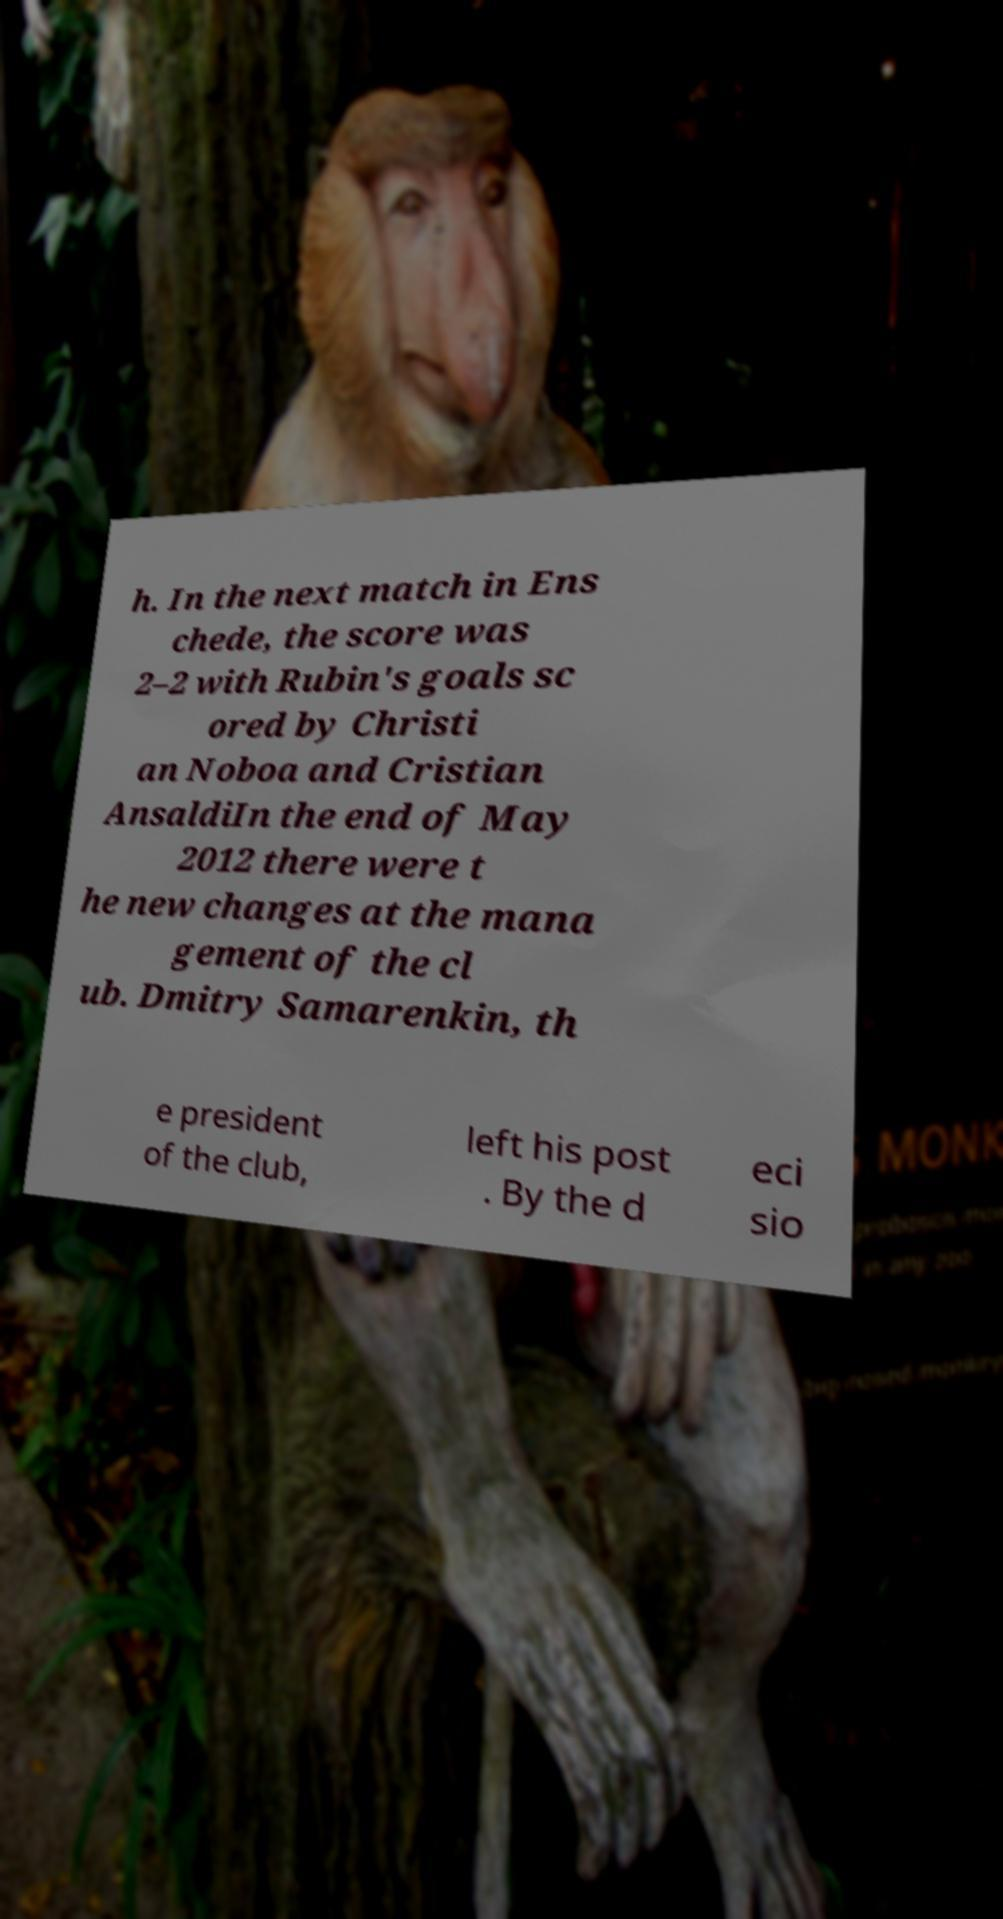What messages or text are displayed in this image? I need them in a readable, typed format. h. In the next match in Ens chede, the score was 2–2 with Rubin's goals sc ored by Christi an Noboa and Cristian AnsaldiIn the end of May 2012 there were t he new changes at the mana gement of the cl ub. Dmitry Samarenkin, th e president of the club, left his post . By the d eci sio 